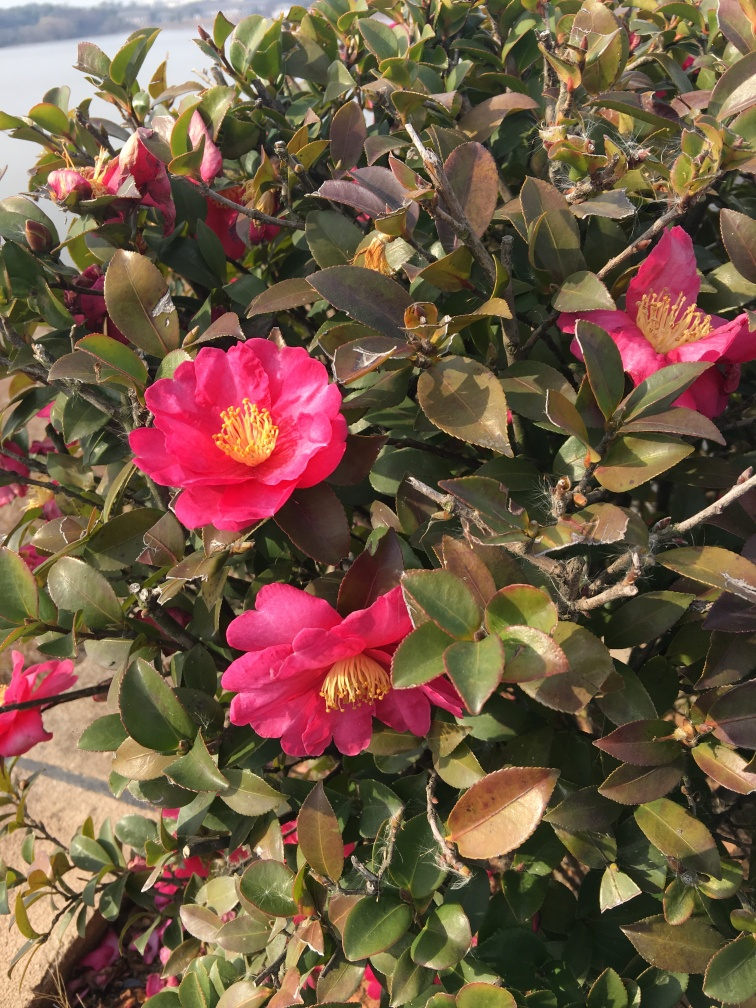What time of year do camellia flowers usually bloom? Camellia flowers tend to bloom in the cooler months of late winter through spring, depending on the specific variety and local climatic conditions. Their ability to provide vibrant color during a time when most other plants are not flowering makes them especially valuable in garden landscapes. 